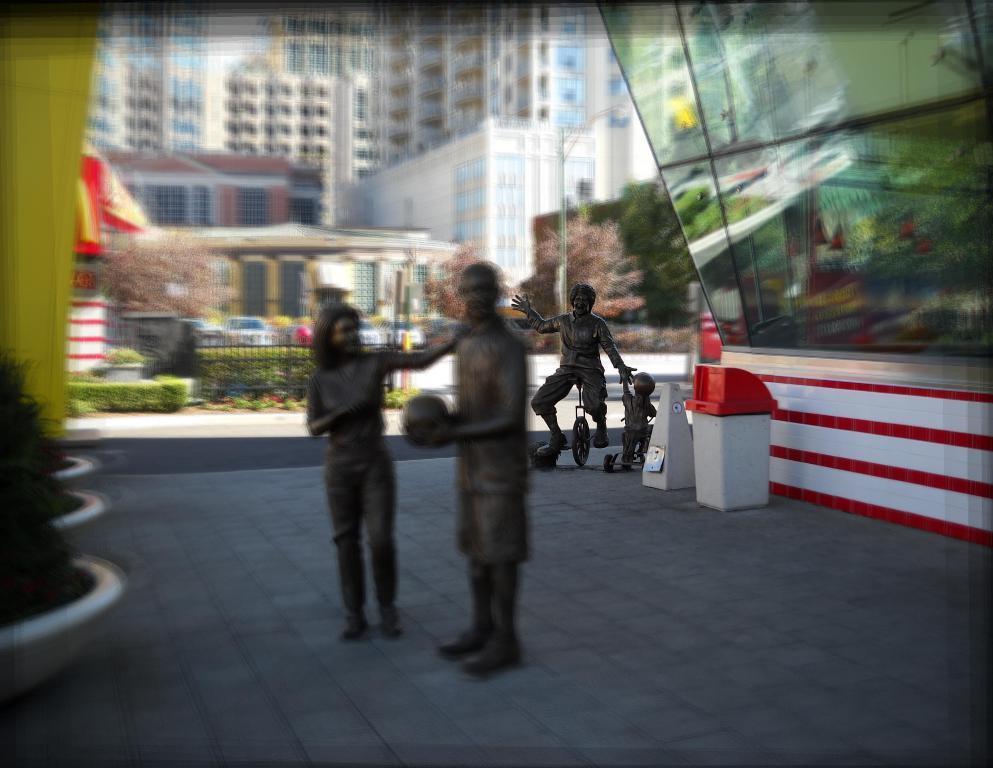Please provide a concise description of this image. In the middle of the image we can see sculptures on the floor. In the background we can see buildings, trees, fence, bushes, street poles, street lights, trash bin, glasses and houseplants. 